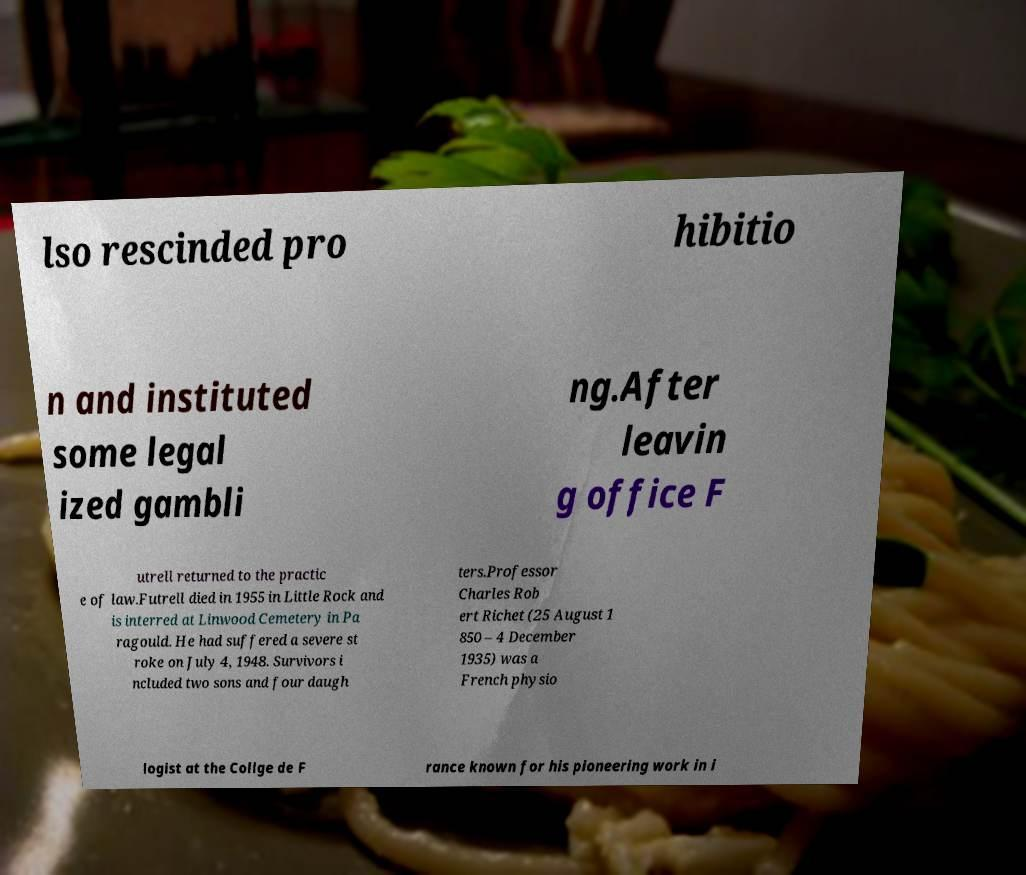Could you assist in decoding the text presented in this image and type it out clearly? lso rescinded pro hibitio n and instituted some legal ized gambli ng.After leavin g office F utrell returned to the practic e of law.Futrell died in 1955 in Little Rock and is interred at Linwood Cemetery in Pa ragould. He had suffered a severe st roke on July 4, 1948. Survivors i ncluded two sons and four daugh ters.Professor Charles Rob ert Richet (25 August 1 850 – 4 December 1935) was a French physio logist at the Collge de F rance known for his pioneering work in i 